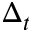<formula> <loc_0><loc_0><loc_500><loc_500>\Delta _ { t }</formula> 